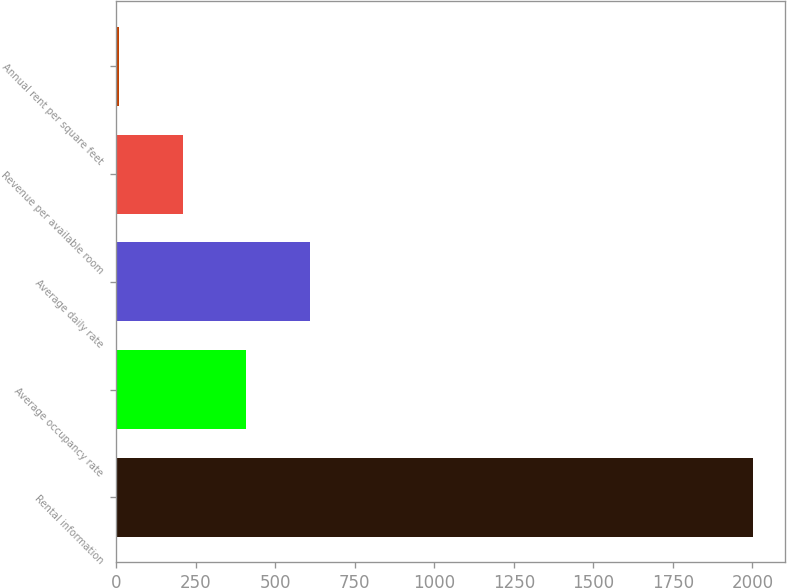Convert chart. <chart><loc_0><loc_0><loc_500><loc_500><bar_chart><fcel>Rental information<fcel>Average occupancy rate<fcel>Average daily rate<fcel>Revenue per available room<fcel>Annual rent per square feet<nl><fcel>2003<fcel>408.54<fcel>607.85<fcel>209.23<fcel>9.92<nl></chart> 